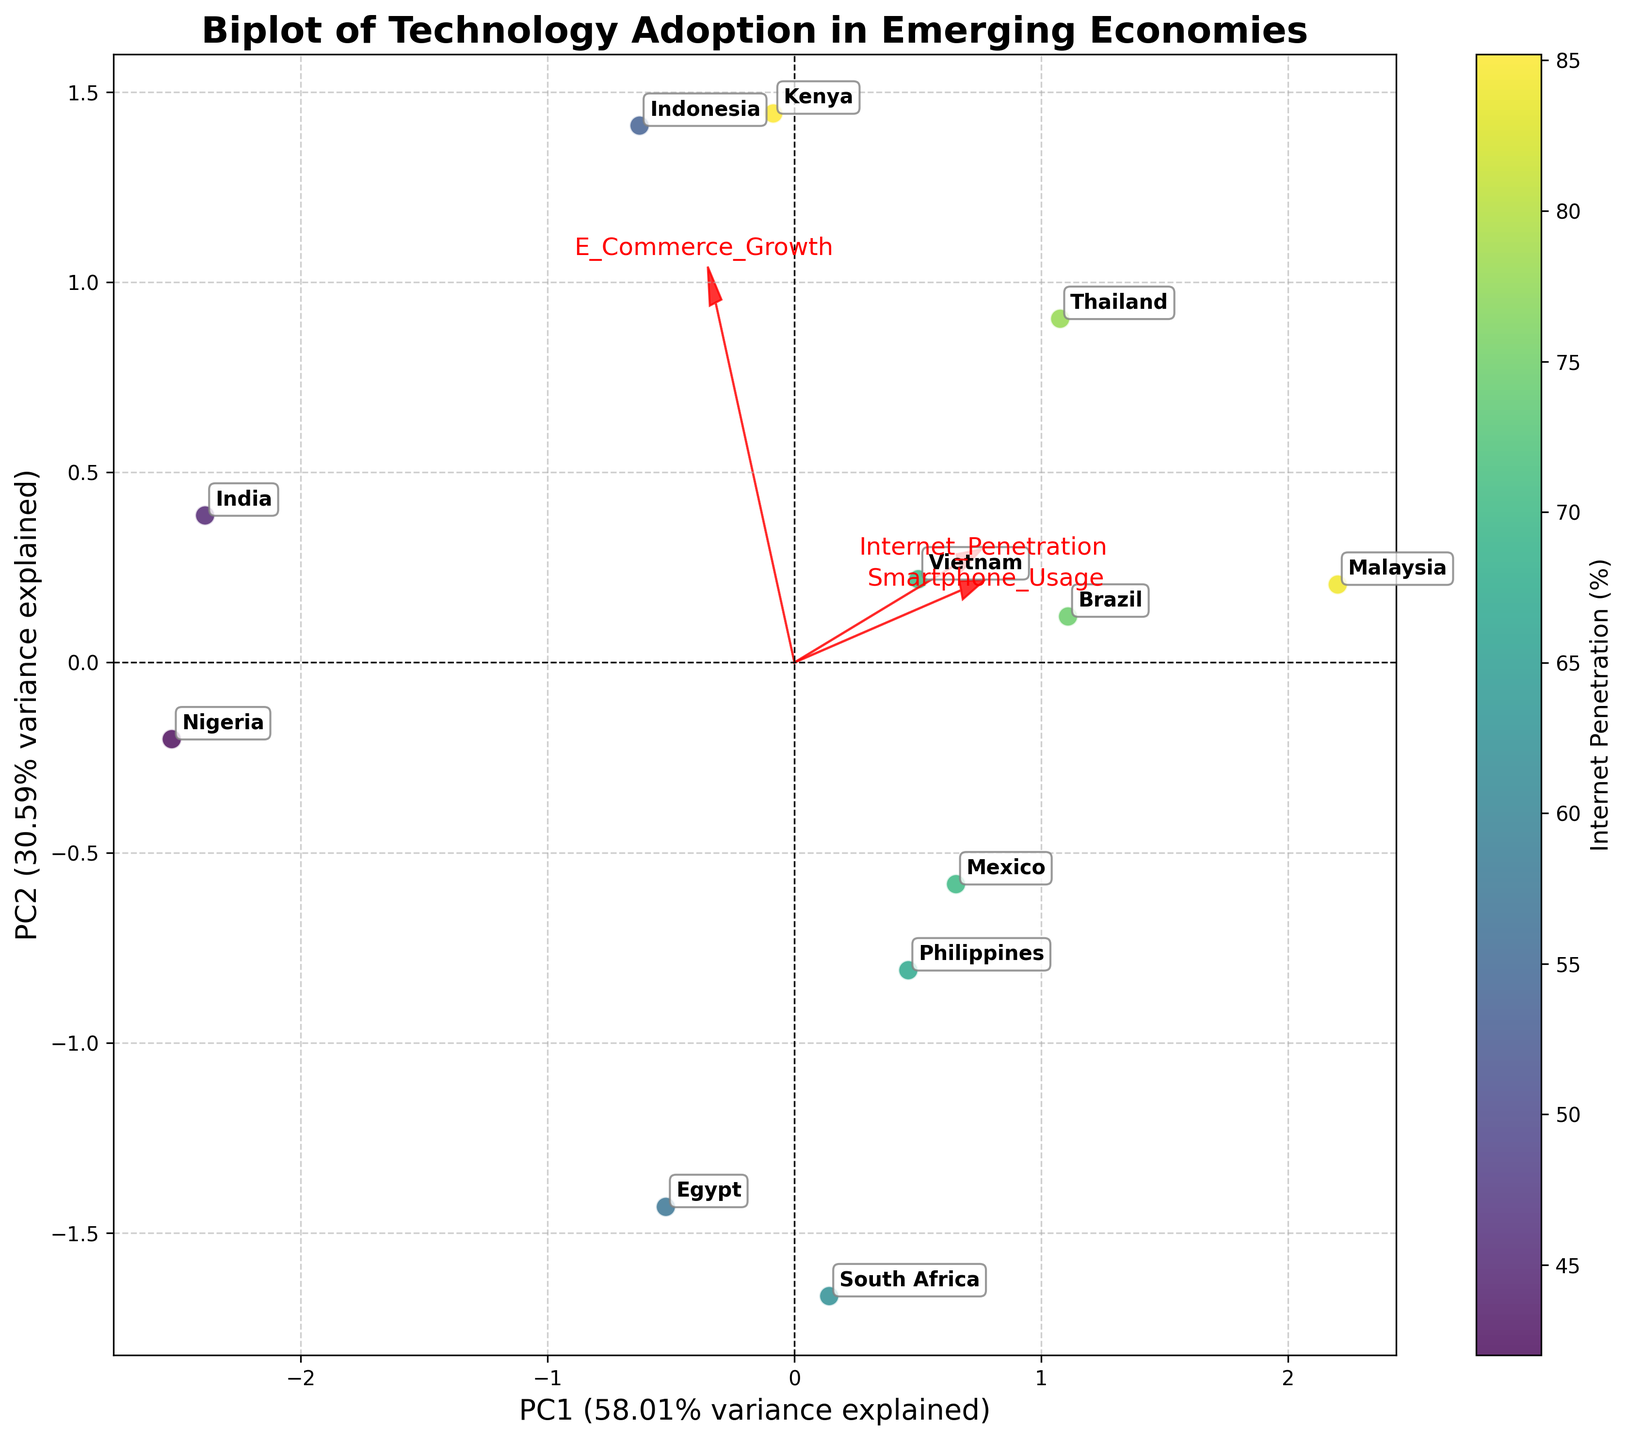What is the title of the plot? The title is usually located at the top-center of the plot. In this case, it says "Biplot of Technology Adoption in Emerging Economies".
Answer: Biplot of Technology Adoption in Emerging Economies How many countries are represented in the biplot? By counting the number of distinct annotations (country names) in the plot, we can determine the number of countries represented.
Answer: 12 Which country is positioned the furthest to the right on the plot? By looking at the x-axis (PC1), the country with the highest value along this axis can be identified.
Answer: Malaysia Which axis explains more variance, PC1 or PC2? The labels next to the x-axis and y-axis show the proportion of variance explained by each principal component. PC1 is labeled with a percentage and similarly PC2. By comparing these percentages, PC1 explains more variance.
Answer: PC1 What is the relationship between the vectors representing 'Internet Penetration' and 'Smartphone Usage'? The vectors' directions and angles in a biplot indicate the relationships. If they are close to parallel, they are positively correlated.
Answer: Positively correlated Which country has the lowest smartphone usage among the ones shown in the plot? The country positioned closest to the direction pointing towards low 'Smartphone Usage' on the plot would have the lowest value in this feature.
Answer: Nigeria Which feature contributes more to PC2, 'E-Commerce Growth' or 'Internet Penetration'? By examining the direction and length of the vector arrows for 'E-Commerce Growth' and 'Internet Penetration' along the y-axis (PC2), the feature with a longer arrow along this axis contributes more.
Answer: E-Commerce Growth How do 'Internet Penetration' and 'E-Commerce Growth' differ in their effect on the first principal component (PC1)? By looking at the arrow lengths and directions along the x-axis (PC1) for 'Internet Penetration' and 'E-Commerce Growth', we can see which has a stronger effect on PC1.
Answer: Internet Penetration has a stronger effect How far to the right is Vietnam positioned compared to Egypt? By noting the positions of Vietnam and Egypt on the x-axis (PC1), the distance between these two positions can be measured horizontally.
Answer: Vietnam is further right than Egypt Which countries are closest to each other in the biplot? By visually inspecting the plot, we can identify which countries' labels are nearest to one another.
Answer: Mexico and Philippines 